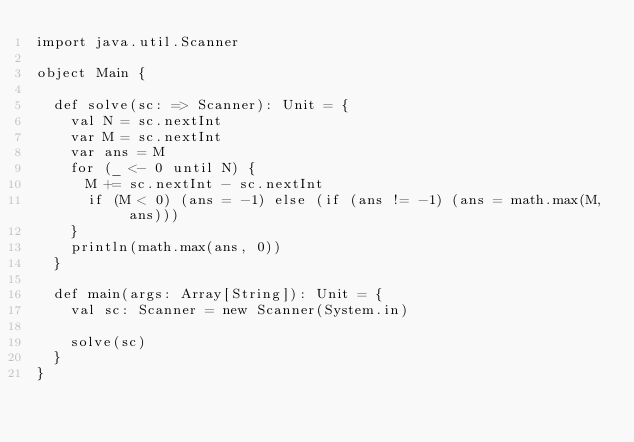<code> <loc_0><loc_0><loc_500><loc_500><_Scala_>import java.util.Scanner

object Main {

  def solve(sc: => Scanner): Unit = {
    val N = sc.nextInt
    var M = sc.nextInt
    var ans = M
    for (_ <- 0 until N) {
      M += sc.nextInt - sc.nextInt
      if (M < 0) (ans = -1) else (if (ans != -1) (ans = math.max(M, ans)))
    }
    println(math.max(ans, 0))
  }

  def main(args: Array[String]): Unit = {
    val sc: Scanner = new Scanner(System.in)

    solve(sc)
  }
}</code> 